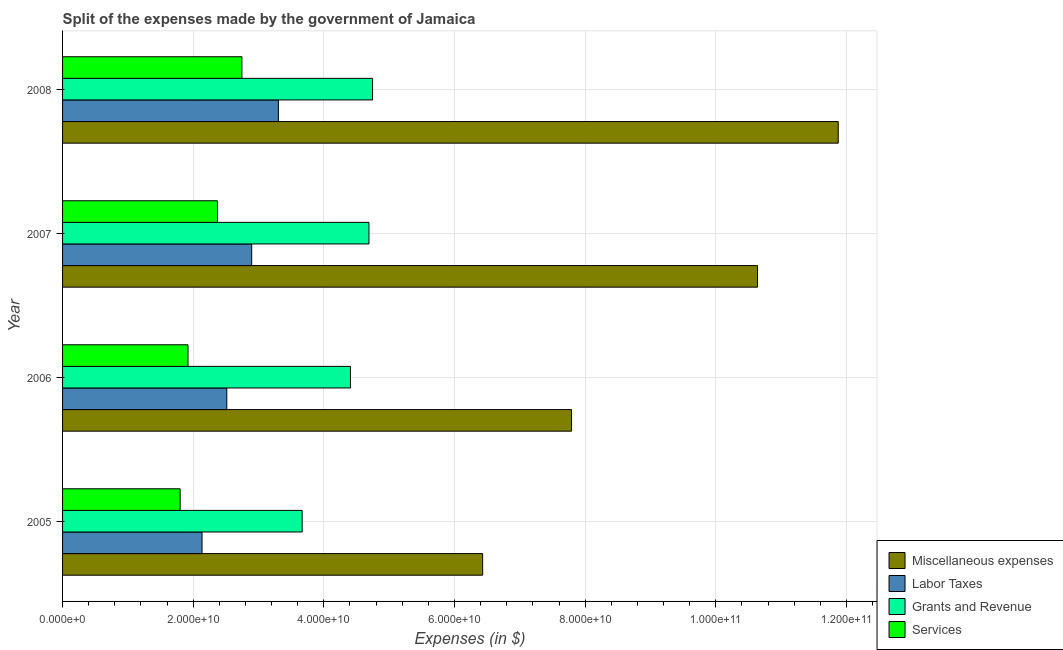How many different coloured bars are there?
Keep it short and to the point. 4. How many bars are there on the 1st tick from the top?
Keep it short and to the point. 4. How many bars are there on the 1st tick from the bottom?
Give a very brief answer. 4. What is the label of the 2nd group of bars from the top?
Ensure brevity in your answer.  2007. What is the amount spent on miscellaneous expenses in 2005?
Offer a terse response. 6.43e+1. Across all years, what is the maximum amount spent on grants and revenue?
Your response must be concise. 4.75e+1. Across all years, what is the minimum amount spent on labor taxes?
Offer a terse response. 2.14e+1. In which year was the amount spent on miscellaneous expenses maximum?
Give a very brief answer. 2008. In which year was the amount spent on miscellaneous expenses minimum?
Your answer should be very brief. 2005. What is the total amount spent on services in the graph?
Give a very brief answer. 8.84e+1. What is the difference between the amount spent on labor taxes in 2007 and that in 2008?
Make the answer very short. -4.09e+09. What is the difference between the amount spent on labor taxes in 2006 and the amount spent on miscellaneous expenses in 2008?
Your answer should be compact. -9.36e+1. What is the average amount spent on services per year?
Provide a short and direct response. 2.21e+1. In the year 2006, what is the difference between the amount spent on labor taxes and amount spent on miscellaneous expenses?
Provide a succinct answer. -5.28e+1. What is the ratio of the amount spent on labor taxes in 2005 to that in 2006?
Keep it short and to the point. 0.85. Is the amount spent on miscellaneous expenses in 2005 less than that in 2006?
Ensure brevity in your answer.  Yes. Is the difference between the amount spent on services in 2005 and 2008 greater than the difference between the amount spent on grants and revenue in 2005 and 2008?
Give a very brief answer. Yes. What is the difference between the highest and the second highest amount spent on miscellaneous expenses?
Offer a terse response. 1.24e+1. What is the difference between the highest and the lowest amount spent on services?
Your response must be concise. 9.46e+09. Is the sum of the amount spent on grants and revenue in 2006 and 2007 greater than the maximum amount spent on labor taxes across all years?
Offer a very short reply. Yes. What does the 3rd bar from the top in 2006 represents?
Your answer should be very brief. Labor Taxes. What does the 3rd bar from the bottom in 2006 represents?
Give a very brief answer. Grants and Revenue. How many bars are there?
Provide a succinct answer. 16. Are all the bars in the graph horizontal?
Your answer should be very brief. Yes. Are the values on the major ticks of X-axis written in scientific E-notation?
Your answer should be compact. Yes. Does the graph contain grids?
Make the answer very short. Yes. Where does the legend appear in the graph?
Your response must be concise. Bottom right. How many legend labels are there?
Ensure brevity in your answer.  4. What is the title of the graph?
Make the answer very short. Split of the expenses made by the government of Jamaica. Does "Overall level" appear as one of the legend labels in the graph?
Give a very brief answer. No. What is the label or title of the X-axis?
Give a very brief answer. Expenses (in $). What is the label or title of the Y-axis?
Offer a terse response. Year. What is the Expenses (in $) of Miscellaneous expenses in 2005?
Your answer should be compact. 6.43e+1. What is the Expenses (in $) of Labor Taxes in 2005?
Ensure brevity in your answer.  2.14e+1. What is the Expenses (in $) in Grants and Revenue in 2005?
Keep it short and to the point. 3.67e+1. What is the Expenses (in $) in Services in 2005?
Keep it short and to the point. 1.80e+1. What is the Expenses (in $) of Miscellaneous expenses in 2006?
Keep it short and to the point. 7.79e+1. What is the Expenses (in $) in Labor Taxes in 2006?
Your answer should be very brief. 2.51e+1. What is the Expenses (in $) in Grants and Revenue in 2006?
Your response must be concise. 4.41e+1. What is the Expenses (in $) in Services in 2006?
Give a very brief answer. 1.92e+1. What is the Expenses (in $) in Miscellaneous expenses in 2007?
Offer a terse response. 1.06e+11. What is the Expenses (in $) in Labor Taxes in 2007?
Offer a very short reply. 2.90e+1. What is the Expenses (in $) in Grants and Revenue in 2007?
Make the answer very short. 4.69e+1. What is the Expenses (in $) of Services in 2007?
Your answer should be very brief. 2.37e+1. What is the Expenses (in $) of Miscellaneous expenses in 2008?
Give a very brief answer. 1.19e+11. What is the Expenses (in $) of Labor Taxes in 2008?
Provide a short and direct response. 3.30e+1. What is the Expenses (in $) in Grants and Revenue in 2008?
Provide a short and direct response. 4.75e+1. What is the Expenses (in $) in Services in 2008?
Offer a very short reply. 2.75e+1. Across all years, what is the maximum Expenses (in $) of Miscellaneous expenses?
Your response must be concise. 1.19e+11. Across all years, what is the maximum Expenses (in $) in Labor Taxes?
Ensure brevity in your answer.  3.30e+1. Across all years, what is the maximum Expenses (in $) in Grants and Revenue?
Keep it short and to the point. 4.75e+1. Across all years, what is the maximum Expenses (in $) in Services?
Keep it short and to the point. 2.75e+1. Across all years, what is the minimum Expenses (in $) of Miscellaneous expenses?
Offer a terse response. 6.43e+1. Across all years, what is the minimum Expenses (in $) in Labor Taxes?
Your answer should be compact. 2.14e+1. Across all years, what is the minimum Expenses (in $) of Grants and Revenue?
Ensure brevity in your answer.  3.67e+1. Across all years, what is the minimum Expenses (in $) in Services?
Provide a succinct answer. 1.80e+1. What is the total Expenses (in $) in Miscellaneous expenses in the graph?
Provide a short and direct response. 3.67e+11. What is the total Expenses (in $) in Labor Taxes in the graph?
Ensure brevity in your answer.  1.08e+11. What is the total Expenses (in $) in Grants and Revenue in the graph?
Your response must be concise. 1.75e+11. What is the total Expenses (in $) of Services in the graph?
Ensure brevity in your answer.  8.84e+1. What is the difference between the Expenses (in $) of Miscellaneous expenses in 2005 and that in 2006?
Keep it short and to the point. -1.36e+1. What is the difference between the Expenses (in $) of Labor Taxes in 2005 and that in 2006?
Your response must be concise. -3.79e+09. What is the difference between the Expenses (in $) in Grants and Revenue in 2005 and that in 2006?
Provide a short and direct response. -7.40e+09. What is the difference between the Expenses (in $) of Services in 2005 and that in 2006?
Provide a short and direct response. -1.20e+09. What is the difference between the Expenses (in $) in Miscellaneous expenses in 2005 and that in 2007?
Provide a succinct answer. -4.21e+1. What is the difference between the Expenses (in $) in Labor Taxes in 2005 and that in 2007?
Offer a very short reply. -7.60e+09. What is the difference between the Expenses (in $) in Grants and Revenue in 2005 and that in 2007?
Ensure brevity in your answer.  -1.02e+1. What is the difference between the Expenses (in $) in Services in 2005 and that in 2007?
Keep it short and to the point. -5.71e+09. What is the difference between the Expenses (in $) of Miscellaneous expenses in 2005 and that in 2008?
Your answer should be compact. -5.44e+1. What is the difference between the Expenses (in $) of Labor Taxes in 2005 and that in 2008?
Your response must be concise. -1.17e+1. What is the difference between the Expenses (in $) in Grants and Revenue in 2005 and that in 2008?
Keep it short and to the point. -1.08e+1. What is the difference between the Expenses (in $) of Services in 2005 and that in 2008?
Your response must be concise. -9.46e+09. What is the difference between the Expenses (in $) in Miscellaneous expenses in 2006 and that in 2007?
Your answer should be compact. -2.85e+1. What is the difference between the Expenses (in $) in Labor Taxes in 2006 and that in 2007?
Give a very brief answer. -3.81e+09. What is the difference between the Expenses (in $) of Grants and Revenue in 2006 and that in 2007?
Ensure brevity in your answer.  -2.83e+09. What is the difference between the Expenses (in $) in Services in 2006 and that in 2007?
Your answer should be very brief. -4.51e+09. What is the difference between the Expenses (in $) in Miscellaneous expenses in 2006 and that in 2008?
Your response must be concise. -4.08e+1. What is the difference between the Expenses (in $) in Labor Taxes in 2006 and that in 2008?
Offer a terse response. -7.90e+09. What is the difference between the Expenses (in $) of Grants and Revenue in 2006 and that in 2008?
Offer a very short reply. -3.39e+09. What is the difference between the Expenses (in $) in Services in 2006 and that in 2008?
Make the answer very short. -8.25e+09. What is the difference between the Expenses (in $) of Miscellaneous expenses in 2007 and that in 2008?
Ensure brevity in your answer.  -1.24e+1. What is the difference between the Expenses (in $) in Labor Taxes in 2007 and that in 2008?
Ensure brevity in your answer.  -4.09e+09. What is the difference between the Expenses (in $) in Grants and Revenue in 2007 and that in 2008?
Ensure brevity in your answer.  -5.56e+08. What is the difference between the Expenses (in $) of Services in 2007 and that in 2008?
Offer a very short reply. -3.74e+09. What is the difference between the Expenses (in $) in Miscellaneous expenses in 2005 and the Expenses (in $) in Labor Taxes in 2006?
Your answer should be very brief. 3.92e+1. What is the difference between the Expenses (in $) of Miscellaneous expenses in 2005 and the Expenses (in $) of Grants and Revenue in 2006?
Offer a very short reply. 2.02e+1. What is the difference between the Expenses (in $) of Miscellaneous expenses in 2005 and the Expenses (in $) of Services in 2006?
Your answer should be compact. 4.51e+1. What is the difference between the Expenses (in $) of Labor Taxes in 2005 and the Expenses (in $) of Grants and Revenue in 2006?
Offer a very short reply. -2.27e+1. What is the difference between the Expenses (in $) in Labor Taxes in 2005 and the Expenses (in $) in Services in 2006?
Offer a very short reply. 2.15e+09. What is the difference between the Expenses (in $) of Grants and Revenue in 2005 and the Expenses (in $) of Services in 2006?
Keep it short and to the point. 1.75e+1. What is the difference between the Expenses (in $) of Miscellaneous expenses in 2005 and the Expenses (in $) of Labor Taxes in 2007?
Your answer should be compact. 3.54e+1. What is the difference between the Expenses (in $) in Miscellaneous expenses in 2005 and the Expenses (in $) in Grants and Revenue in 2007?
Your answer should be compact. 1.74e+1. What is the difference between the Expenses (in $) in Miscellaneous expenses in 2005 and the Expenses (in $) in Services in 2007?
Offer a very short reply. 4.06e+1. What is the difference between the Expenses (in $) of Labor Taxes in 2005 and the Expenses (in $) of Grants and Revenue in 2007?
Offer a terse response. -2.56e+1. What is the difference between the Expenses (in $) of Labor Taxes in 2005 and the Expenses (in $) of Services in 2007?
Offer a terse response. -2.36e+09. What is the difference between the Expenses (in $) in Grants and Revenue in 2005 and the Expenses (in $) in Services in 2007?
Provide a short and direct response. 1.30e+1. What is the difference between the Expenses (in $) of Miscellaneous expenses in 2005 and the Expenses (in $) of Labor Taxes in 2008?
Make the answer very short. 3.13e+1. What is the difference between the Expenses (in $) in Miscellaneous expenses in 2005 and the Expenses (in $) in Grants and Revenue in 2008?
Make the answer very short. 1.69e+1. What is the difference between the Expenses (in $) in Miscellaneous expenses in 2005 and the Expenses (in $) in Services in 2008?
Provide a short and direct response. 3.69e+1. What is the difference between the Expenses (in $) of Labor Taxes in 2005 and the Expenses (in $) of Grants and Revenue in 2008?
Your answer should be very brief. -2.61e+1. What is the difference between the Expenses (in $) of Labor Taxes in 2005 and the Expenses (in $) of Services in 2008?
Ensure brevity in your answer.  -6.11e+09. What is the difference between the Expenses (in $) in Grants and Revenue in 2005 and the Expenses (in $) in Services in 2008?
Provide a succinct answer. 9.22e+09. What is the difference between the Expenses (in $) in Miscellaneous expenses in 2006 and the Expenses (in $) in Labor Taxes in 2007?
Offer a very short reply. 4.90e+1. What is the difference between the Expenses (in $) of Miscellaneous expenses in 2006 and the Expenses (in $) of Grants and Revenue in 2007?
Your answer should be very brief. 3.10e+1. What is the difference between the Expenses (in $) of Miscellaneous expenses in 2006 and the Expenses (in $) of Services in 2007?
Ensure brevity in your answer.  5.42e+1. What is the difference between the Expenses (in $) in Labor Taxes in 2006 and the Expenses (in $) in Grants and Revenue in 2007?
Ensure brevity in your answer.  -2.18e+1. What is the difference between the Expenses (in $) of Labor Taxes in 2006 and the Expenses (in $) of Services in 2007?
Make the answer very short. 1.43e+09. What is the difference between the Expenses (in $) in Grants and Revenue in 2006 and the Expenses (in $) in Services in 2007?
Provide a succinct answer. 2.04e+1. What is the difference between the Expenses (in $) of Miscellaneous expenses in 2006 and the Expenses (in $) of Labor Taxes in 2008?
Your answer should be very brief. 4.49e+1. What is the difference between the Expenses (in $) of Miscellaneous expenses in 2006 and the Expenses (in $) of Grants and Revenue in 2008?
Offer a very short reply. 3.05e+1. What is the difference between the Expenses (in $) of Miscellaneous expenses in 2006 and the Expenses (in $) of Services in 2008?
Keep it short and to the point. 5.05e+1. What is the difference between the Expenses (in $) of Labor Taxes in 2006 and the Expenses (in $) of Grants and Revenue in 2008?
Offer a very short reply. -2.23e+1. What is the difference between the Expenses (in $) of Labor Taxes in 2006 and the Expenses (in $) of Services in 2008?
Provide a succinct answer. -2.32e+09. What is the difference between the Expenses (in $) of Grants and Revenue in 2006 and the Expenses (in $) of Services in 2008?
Make the answer very short. 1.66e+1. What is the difference between the Expenses (in $) of Miscellaneous expenses in 2007 and the Expenses (in $) of Labor Taxes in 2008?
Make the answer very short. 7.34e+1. What is the difference between the Expenses (in $) in Miscellaneous expenses in 2007 and the Expenses (in $) in Grants and Revenue in 2008?
Keep it short and to the point. 5.89e+1. What is the difference between the Expenses (in $) in Miscellaneous expenses in 2007 and the Expenses (in $) in Services in 2008?
Provide a succinct answer. 7.89e+1. What is the difference between the Expenses (in $) in Labor Taxes in 2007 and the Expenses (in $) in Grants and Revenue in 2008?
Offer a terse response. -1.85e+1. What is the difference between the Expenses (in $) in Labor Taxes in 2007 and the Expenses (in $) in Services in 2008?
Ensure brevity in your answer.  1.50e+09. What is the difference between the Expenses (in $) of Grants and Revenue in 2007 and the Expenses (in $) of Services in 2008?
Your answer should be very brief. 1.94e+1. What is the average Expenses (in $) in Miscellaneous expenses per year?
Ensure brevity in your answer.  9.18e+1. What is the average Expenses (in $) of Labor Taxes per year?
Your answer should be very brief. 2.71e+1. What is the average Expenses (in $) in Grants and Revenue per year?
Give a very brief answer. 4.38e+1. What is the average Expenses (in $) in Services per year?
Your answer should be compact. 2.21e+1. In the year 2005, what is the difference between the Expenses (in $) of Miscellaneous expenses and Expenses (in $) of Labor Taxes?
Offer a very short reply. 4.30e+1. In the year 2005, what is the difference between the Expenses (in $) in Miscellaneous expenses and Expenses (in $) in Grants and Revenue?
Your answer should be very brief. 2.76e+1. In the year 2005, what is the difference between the Expenses (in $) in Miscellaneous expenses and Expenses (in $) in Services?
Give a very brief answer. 4.63e+1. In the year 2005, what is the difference between the Expenses (in $) of Labor Taxes and Expenses (in $) of Grants and Revenue?
Provide a succinct answer. -1.53e+1. In the year 2005, what is the difference between the Expenses (in $) of Labor Taxes and Expenses (in $) of Services?
Provide a short and direct response. 3.35e+09. In the year 2005, what is the difference between the Expenses (in $) in Grants and Revenue and Expenses (in $) in Services?
Provide a short and direct response. 1.87e+1. In the year 2006, what is the difference between the Expenses (in $) in Miscellaneous expenses and Expenses (in $) in Labor Taxes?
Your answer should be very brief. 5.28e+1. In the year 2006, what is the difference between the Expenses (in $) in Miscellaneous expenses and Expenses (in $) in Grants and Revenue?
Your response must be concise. 3.38e+1. In the year 2006, what is the difference between the Expenses (in $) of Miscellaneous expenses and Expenses (in $) of Services?
Keep it short and to the point. 5.87e+1. In the year 2006, what is the difference between the Expenses (in $) in Labor Taxes and Expenses (in $) in Grants and Revenue?
Your answer should be compact. -1.89e+1. In the year 2006, what is the difference between the Expenses (in $) in Labor Taxes and Expenses (in $) in Services?
Keep it short and to the point. 5.94e+09. In the year 2006, what is the difference between the Expenses (in $) of Grants and Revenue and Expenses (in $) of Services?
Your response must be concise. 2.49e+1. In the year 2007, what is the difference between the Expenses (in $) in Miscellaneous expenses and Expenses (in $) in Labor Taxes?
Provide a succinct answer. 7.74e+1. In the year 2007, what is the difference between the Expenses (in $) in Miscellaneous expenses and Expenses (in $) in Grants and Revenue?
Your response must be concise. 5.95e+1. In the year 2007, what is the difference between the Expenses (in $) in Miscellaneous expenses and Expenses (in $) in Services?
Provide a succinct answer. 8.27e+1. In the year 2007, what is the difference between the Expenses (in $) of Labor Taxes and Expenses (in $) of Grants and Revenue?
Offer a very short reply. -1.80e+1. In the year 2007, what is the difference between the Expenses (in $) in Labor Taxes and Expenses (in $) in Services?
Provide a short and direct response. 5.24e+09. In the year 2007, what is the difference between the Expenses (in $) of Grants and Revenue and Expenses (in $) of Services?
Provide a succinct answer. 2.32e+1. In the year 2008, what is the difference between the Expenses (in $) in Miscellaneous expenses and Expenses (in $) in Labor Taxes?
Your answer should be compact. 8.57e+1. In the year 2008, what is the difference between the Expenses (in $) in Miscellaneous expenses and Expenses (in $) in Grants and Revenue?
Keep it short and to the point. 7.13e+1. In the year 2008, what is the difference between the Expenses (in $) of Miscellaneous expenses and Expenses (in $) of Services?
Offer a very short reply. 9.13e+1. In the year 2008, what is the difference between the Expenses (in $) of Labor Taxes and Expenses (in $) of Grants and Revenue?
Offer a terse response. -1.44e+1. In the year 2008, what is the difference between the Expenses (in $) in Labor Taxes and Expenses (in $) in Services?
Make the answer very short. 5.58e+09. In the year 2008, what is the difference between the Expenses (in $) of Grants and Revenue and Expenses (in $) of Services?
Offer a terse response. 2.00e+1. What is the ratio of the Expenses (in $) of Miscellaneous expenses in 2005 to that in 2006?
Your response must be concise. 0.83. What is the ratio of the Expenses (in $) in Labor Taxes in 2005 to that in 2006?
Your answer should be compact. 0.85. What is the ratio of the Expenses (in $) in Grants and Revenue in 2005 to that in 2006?
Keep it short and to the point. 0.83. What is the ratio of the Expenses (in $) in Services in 2005 to that in 2006?
Your response must be concise. 0.94. What is the ratio of the Expenses (in $) in Miscellaneous expenses in 2005 to that in 2007?
Give a very brief answer. 0.6. What is the ratio of the Expenses (in $) of Labor Taxes in 2005 to that in 2007?
Give a very brief answer. 0.74. What is the ratio of the Expenses (in $) of Grants and Revenue in 2005 to that in 2007?
Your answer should be compact. 0.78. What is the ratio of the Expenses (in $) of Services in 2005 to that in 2007?
Offer a very short reply. 0.76. What is the ratio of the Expenses (in $) of Miscellaneous expenses in 2005 to that in 2008?
Provide a short and direct response. 0.54. What is the ratio of the Expenses (in $) of Labor Taxes in 2005 to that in 2008?
Give a very brief answer. 0.65. What is the ratio of the Expenses (in $) of Grants and Revenue in 2005 to that in 2008?
Make the answer very short. 0.77. What is the ratio of the Expenses (in $) of Services in 2005 to that in 2008?
Ensure brevity in your answer.  0.66. What is the ratio of the Expenses (in $) in Miscellaneous expenses in 2006 to that in 2007?
Make the answer very short. 0.73. What is the ratio of the Expenses (in $) of Labor Taxes in 2006 to that in 2007?
Your answer should be very brief. 0.87. What is the ratio of the Expenses (in $) in Grants and Revenue in 2006 to that in 2007?
Your answer should be compact. 0.94. What is the ratio of the Expenses (in $) in Services in 2006 to that in 2007?
Your answer should be compact. 0.81. What is the ratio of the Expenses (in $) of Miscellaneous expenses in 2006 to that in 2008?
Your response must be concise. 0.66. What is the ratio of the Expenses (in $) in Labor Taxes in 2006 to that in 2008?
Make the answer very short. 0.76. What is the ratio of the Expenses (in $) of Grants and Revenue in 2006 to that in 2008?
Ensure brevity in your answer.  0.93. What is the ratio of the Expenses (in $) of Services in 2006 to that in 2008?
Offer a terse response. 0.7. What is the ratio of the Expenses (in $) of Miscellaneous expenses in 2007 to that in 2008?
Ensure brevity in your answer.  0.9. What is the ratio of the Expenses (in $) in Labor Taxes in 2007 to that in 2008?
Your answer should be compact. 0.88. What is the ratio of the Expenses (in $) in Grants and Revenue in 2007 to that in 2008?
Offer a very short reply. 0.99. What is the ratio of the Expenses (in $) of Services in 2007 to that in 2008?
Keep it short and to the point. 0.86. What is the difference between the highest and the second highest Expenses (in $) of Miscellaneous expenses?
Ensure brevity in your answer.  1.24e+1. What is the difference between the highest and the second highest Expenses (in $) in Labor Taxes?
Offer a terse response. 4.09e+09. What is the difference between the highest and the second highest Expenses (in $) of Grants and Revenue?
Offer a very short reply. 5.56e+08. What is the difference between the highest and the second highest Expenses (in $) of Services?
Offer a very short reply. 3.74e+09. What is the difference between the highest and the lowest Expenses (in $) in Miscellaneous expenses?
Make the answer very short. 5.44e+1. What is the difference between the highest and the lowest Expenses (in $) in Labor Taxes?
Your answer should be very brief. 1.17e+1. What is the difference between the highest and the lowest Expenses (in $) of Grants and Revenue?
Provide a short and direct response. 1.08e+1. What is the difference between the highest and the lowest Expenses (in $) in Services?
Your answer should be compact. 9.46e+09. 